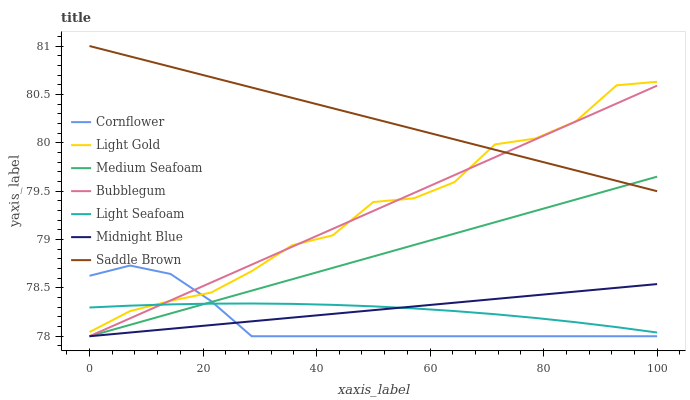Does Midnight Blue have the minimum area under the curve?
Answer yes or no. No. Does Midnight Blue have the maximum area under the curve?
Answer yes or no. No. Is Midnight Blue the smoothest?
Answer yes or no. No. Is Midnight Blue the roughest?
Answer yes or no. No. Does Saddle Brown have the lowest value?
Answer yes or no. No. Does Midnight Blue have the highest value?
Answer yes or no. No. Is Midnight Blue less than Saddle Brown?
Answer yes or no. Yes. Is Light Gold greater than Midnight Blue?
Answer yes or no. Yes. Does Midnight Blue intersect Saddle Brown?
Answer yes or no. No. 